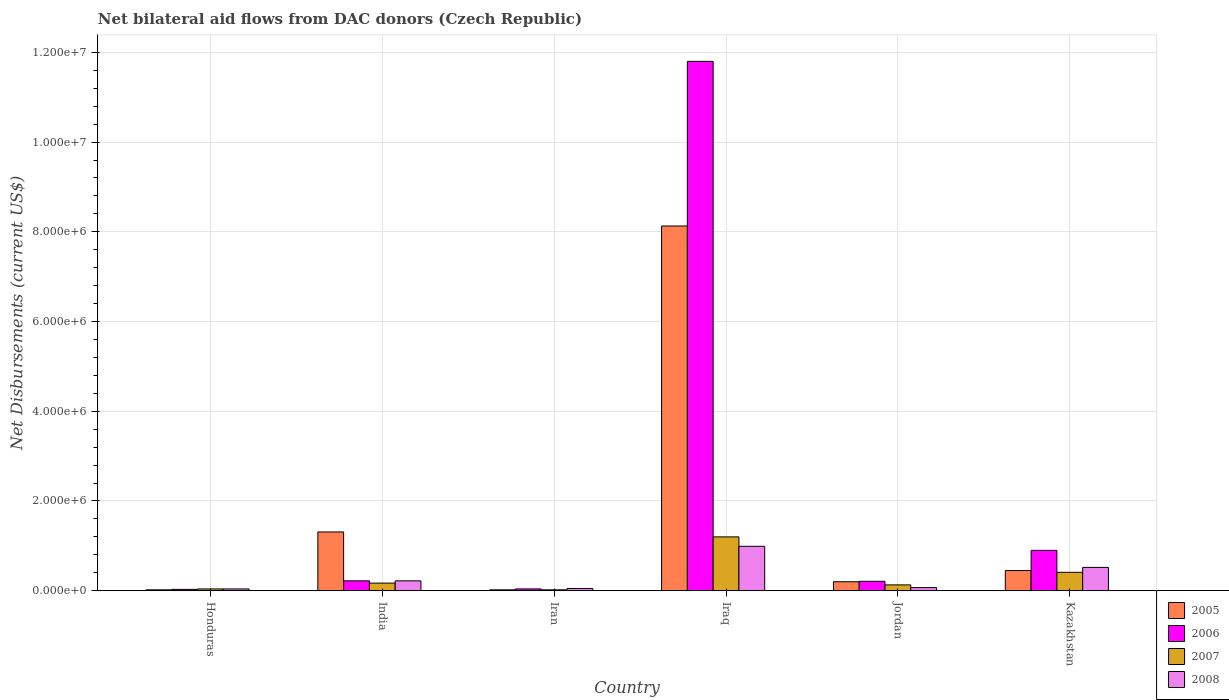How many different coloured bars are there?
Your answer should be very brief. 4. Are the number of bars per tick equal to the number of legend labels?
Provide a succinct answer. Yes. Are the number of bars on each tick of the X-axis equal?
Offer a terse response. Yes. How many bars are there on the 5th tick from the left?
Make the answer very short. 4. In how many cases, is the number of bars for a given country not equal to the number of legend labels?
Offer a very short reply. 0. Across all countries, what is the maximum net bilateral aid flows in 2007?
Provide a short and direct response. 1.20e+06. In which country was the net bilateral aid flows in 2006 maximum?
Provide a succinct answer. Iraq. In which country was the net bilateral aid flows in 2007 minimum?
Ensure brevity in your answer.  Iran. What is the total net bilateral aid flows in 2007 in the graph?
Offer a very short reply. 1.97e+06. What is the difference between the net bilateral aid flows in 2006 in Honduras and that in Iran?
Offer a very short reply. -10000. What is the difference between the net bilateral aid flows in 2007 in Iran and the net bilateral aid flows in 2005 in Jordan?
Your answer should be compact. -1.80e+05. What is the average net bilateral aid flows in 2008 per country?
Offer a terse response. 3.15e+05. Is the difference between the net bilateral aid flows in 2005 in Honduras and Jordan greater than the difference between the net bilateral aid flows in 2006 in Honduras and Jordan?
Keep it short and to the point. No. What is the difference between the highest and the second highest net bilateral aid flows in 2005?
Provide a short and direct response. 6.82e+06. What is the difference between the highest and the lowest net bilateral aid flows in 2006?
Offer a terse response. 1.18e+07. In how many countries, is the net bilateral aid flows in 2006 greater than the average net bilateral aid flows in 2006 taken over all countries?
Give a very brief answer. 1. Is the sum of the net bilateral aid flows in 2005 in Iran and Iraq greater than the maximum net bilateral aid flows in 2008 across all countries?
Your answer should be compact. Yes. What does the 4th bar from the right in Honduras represents?
Your answer should be very brief. 2005. Is it the case that in every country, the sum of the net bilateral aid flows in 2008 and net bilateral aid flows in 2006 is greater than the net bilateral aid flows in 2005?
Keep it short and to the point. No. How many countries are there in the graph?
Provide a short and direct response. 6. What is the difference between two consecutive major ticks on the Y-axis?
Provide a short and direct response. 2.00e+06. Does the graph contain grids?
Offer a terse response. Yes. What is the title of the graph?
Give a very brief answer. Net bilateral aid flows from DAC donors (Czech Republic). Does "1960" appear as one of the legend labels in the graph?
Give a very brief answer. No. What is the label or title of the X-axis?
Your answer should be very brief. Country. What is the label or title of the Y-axis?
Your answer should be very brief. Net Disbursements (current US$). What is the Net Disbursements (current US$) in 2005 in Honduras?
Your answer should be very brief. 2.00e+04. What is the Net Disbursements (current US$) in 2006 in Honduras?
Ensure brevity in your answer.  3.00e+04. What is the Net Disbursements (current US$) in 2007 in Honduras?
Your response must be concise. 4.00e+04. What is the Net Disbursements (current US$) of 2008 in Honduras?
Offer a terse response. 4.00e+04. What is the Net Disbursements (current US$) in 2005 in India?
Make the answer very short. 1.31e+06. What is the Net Disbursements (current US$) of 2007 in Iran?
Provide a succinct answer. 2.00e+04. What is the Net Disbursements (current US$) of 2008 in Iran?
Keep it short and to the point. 5.00e+04. What is the Net Disbursements (current US$) in 2005 in Iraq?
Keep it short and to the point. 8.13e+06. What is the Net Disbursements (current US$) in 2006 in Iraq?
Offer a very short reply. 1.18e+07. What is the Net Disbursements (current US$) in 2007 in Iraq?
Offer a terse response. 1.20e+06. What is the Net Disbursements (current US$) of 2008 in Iraq?
Give a very brief answer. 9.90e+05. What is the Net Disbursements (current US$) in 2006 in Kazakhstan?
Your response must be concise. 9.00e+05. What is the Net Disbursements (current US$) of 2008 in Kazakhstan?
Offer a very short reply. 5.20e+05. Across all countries, what is the maximum Net Disbursements (current US$) of 2005?
Offer a terse response. 8.13e+06. Across all countries, what is the maximum Net Disbursements (current US$) of 2006?
Offer a terse response. 1.18e+07. Across all countries, what is the maximum Net Disbursements (current US$) of 2007?
Ensure brevity in your answer.  1.20e+06. Across all countries, what is the maximum Net Disbursements (current US$) in 2008?
Your response must be concise. 9.90e+05. Across all countries, what is the minimum Net Disbursements (current US$) in 2005?
Provide a short and direct response. 2.00e+04. Across all countries, what is the minimum Net Disbursements (current US$) of 2006?
Keep it short and to the point. 3.00e+04. Across all countries, what is the minimum Net Disbursements (current US$) in 2007?
Your response must be concise. 2.00e+04. Across all countries, what is the minimum Net Disbursements (current US$) in 2008?
Provide a short and direct response. 4.00e+04. What is the total Net Disbursements (current US$) of 2005 in the graph?
Your response must be concise. 1.01e+07. What is the total Net Disbursements (current US$) in 2006 in the graph?
Your answer should be compact. 1.32e+07. What is the total Net Disbursements (current US$) in 2007 in the graph?
Your answer should be compact. 1.97e+06. What is the total Net Disbursements (current US$) of 2008 in the graph?
Your answer should be very brief. 1.89e+06. What is the difference between the Net Disbursements (current US$) in 2005 in Honduras and that in India?
Provide a short and direct response. -1.29e+06. What is the difference between the Net Disbursements (current US$) of 2005 in Honduras and that in Iran?
Offer a terse response. 0. What is the difference between the Net Disbursements (current US$) of 2007 in Honduras and that in Iran?
Your response must be concise. 2.00e+04. What is the difference between the Net Disbursements (current US$) in 2008 in Honduras and that in Iran?
Ensure brevity in your answer.  -10000. What is the difference between the Net Disbursements (current US$) of 2005 in Honduras and that in Iraq?
Provide a short and direct response. -8.11e+06. What is the difference between the Net Disbursements (current US$) in 2006 in Honduras and that in Iraq?
Your response must be concise. -1.18e+07. What is the difference between the Net Disbursements (current US$) of 2007 in Honduras and that in Iraq?
Keep it short and to the point. -1.16e+06. What is the difference between the Net Disbursements (current US$) in 2008 in Honduras and that in Iraq?
Make the answer very short. -9.50e+05. What is the difference between the Net Disbursements (current US$) of 2005 in Honduras and that in Jordan?
Make the answer very short. -1.80e+05. What is the difference between the Net Disbursements (current US$) in 2007 in Honduras and that in Jordan?
Your answer should be compact. -9.00e+04. What is the difference between the Net Disbursements (current US$) of 2008 in Honduras and that in Jordan?
Your answer should be compact. -3.00e+04. What is the difference between the Net Disbursements (current US$) of 2005 in Honduras and that in Kazakhstan?
Offer a very short reply. -4.30e+05. What is the difference between the Net Disbursements (current US$) in 2006 in Honduras and that in Kazakhstan?
Offer a very short reply. -8.70e+05. What is the difference between the Net Disbursements (current US$) in 2007 in Honduras and that in Kazakhstan?
Provide a succinct answer. -3.70e+05. What is the difference between the Net Disbursements (current US$) of 2008 in Honduras and that in Kazakhstan?
Give a very brief answer. -4.80e+05. What is the difference between the Net Disbursements (current US$) in 2005 in India and that in Iran?
Your answer should be compact. 1.29e+06. What is the difference between the Net Disbursements (current US$) in 2005 in India and that in Iraq?
Your response must be concise. -6.82e+06. What is the difference between the Net Disbursements (current US$) in 2006 in India and that in Iraq?
Give a very brief answer. -1.16e+07. What is the difference between the Net Disbursements (current US$) of 2007 in India and that in Iraq?
Offer a very short reply. -1.03e+06. What is the difference between the Net Disbursements (current US$) in 2008 in India and that in Iraq?
Make the answer very short. -7.70e+05. What is the difference between the Net Disbursements (current US$) in 2005 in India and that in Jordan?
Offer a very short reply. 1.11e+06. What is the difference between the Net Disbursements (current US$) in 2006 in India and that in Jordan?
Make the answer very short. 10000. What is the difference between the Net Disbursements (current US$) of 2007 in India and that in Jordan?
Make the answer very short. 4.00e+04. What is the difference between the Net Disbursements (current US$) of 2005 in India and that in Kazakhstan?
Provide a succinct answer. 8.60e+05. What is the difference between the Net Disbursements (current US$) in 2006 in India and that in Kazakhstan?
Offer a very short reply. -6.80e+05. What is the difference between the Net Disbursements (current US$) of 2007 in India and that in Kazakhstan?
Offer a very short reply. -2.40e+05. What is the difference between the Net Disbursements (current US$) in 2008 in India and that in Kazakhstan?
Offer a very short reply. -3.00e+05. What is the difference between the Net Disbursements (current US$) of 2005 in Iran and that in Iraq?
Ensure brevity in your answer.  -8.11e+06. What is the difference between the Net Disbursements (current US$) in 2006 in Iran and that in Iraq?
Offer a very short reply. -1.18e+07. What is the difference between the Net Disbursements (current US$) in 2007 in Iran and that in Iraq?
Give a very brief answer. -1.18e+06. What is the difference between the Net Disbursements (current US$) in 2008 in Iran and that in Iraq?
Offer a very short reply. -9.40e+05. What is the difference between the Net Disbursements (current US$) in 2005 in Iran and that in Jordan?
Keep it short and to the point. -1.80e+05. What is the difference between the Net Disbursements (current US$) in 2007 in Iran and that in Jordan?
Make the answer very short. -1.10e+05. What is the difference between the Net Disbursements (current US$) in 2005 in Iran and that in Kazakhstan?
Keep it short and to the point. -4.30e+05. What is the difference between the Net Disbursements (current US$) in 2006 in Iran and that in Kazakhstan?
Keep it short and to the point. -8.60e+05. What is the difference between the Net Disbursements (current US$) of 2007 in Iran and that in Kazakhstan?
Keep it short and to the point. -3.90e+05. What is the difference between the Net Disbursements (current US$) in 2008 in Iran and that in Kazakhstan?
Provide a short and direct response. -4.70e+05. What is the difference between the Net Disbursements (current US$) in 2005 in Iraq and that in Jordan?
Give a very brief answer. 7.93e+06. What is the difference between the Net Disbursements (current US$) in 2006 in Iraq and that in Jordan?
Provide a succinct answer. 1.16e+07. What is the difference between the Net Disbursements (current US$) in 2007 in Iraq and that in Jordan?
Provide a succinct answer. 1.07e+06. What is the difference between the Net Disbursements (current US$) in 2008 in Iraq and that in Jordan?
Ensure brevity in your answer.  9.20e+05. What is the difference between the Net Disbursements (current US$) in 2005 in Iraq and that in Kazakhstan?
Offer a terse response. 7.68e+06. What is the difference between the Net Disbursements (current US$) of 2006 in Iraq and that in Kazakhstan?
Keep it short and to the point. 1.09e+07. What is the difference between the Net Disbursements (current US$) of 2007 in Iraq and that in Kazakhstan?
Offer a very short reply. 7.90e+05. What is the difference between the Net Disbursements (current US$) of 2006 in Jordan and that in Kazakhstan?
Keep it short and to the point. -6.90e+05. What is the difference between the Net Disbursements (current US$) in 2007 in Jordan and that in Kazakhstan?
Your answer should be very brief. -2.80e+05. What is the difference between the Net Disbursements (current US$) in 2008 in Jordan and that in Kazakhstan?
Give a very brief answer. -4.50e+05. What is the difference between the Net Disbursements (current US$) of 2005 in Honduras and the Net Disbursements (current US$) of 2006 in India?
Offer a very short reply. -2.00e+05. What is the difference between the Net Disbursements (current US$) of 2005 in Honduras and the Net Disbursements (current US$) of 2007 in Iran?
Keep it short and to the point. 0. What is the difference between the Net Disbursements (current US$) of 2006 in Honduras and the Net Disbursements (current US$) of 2007 in Iran?
Your answer should be compact. 10000. What is the difference between the Net Disbursements (current US$) of 2006 in Honduras and the Net Disbursements (current US$) of 2008 in Iran?
Your answer should be compact. -2.00e+04. What is the difference between the Net Disbursements (current US$) of 2005 in Honduras and the Net Disbursements (current US$) of 2006 in Iraq?
Your answer should be very brief. -1.18e+07. What is the difference between the Net Disbursements (current US$) in 2005 in Honduras and the Net Disbursements (current US$) in 2007 in Iraq?
Offer a terse response. -1.18e+06. What is the difference between the Net Disbursements (current US$) in 2005 in Honduras and the Net Disbursements (current US$) in 2008 in Iraq?
Your answer should be very brief. -9.70e+05. What is the difference between the Net Disbursements (current US$) of 2006 in Honduras and the Net Disbursements (current US$) of 2007 in Iraq?
Provide a short and direct response. -1.17e+06. What is the difference between the Net Disbursements (current US$) in 2006 in Honduras and the Net Disbursements (current US$) in 2008 in Iraq?
Offer a terse response. -9.60e+05. What is the difference between the Net Disbursements (current US$) of 2007 in Honduras and the Net Disbursements (current US$) of 2008 in Iraq?
Offer a very short reply. -9.50e+05. What is the difference between the Net Disbursements (current US$) of 2005 in Honduras and the Net Disbursements (current US$) of 2006 in Jordan?
Give a very brief answer. -1.90e+05. What is the difference between the Net Disbursements (current US$) in 2005 in Honduras and the Net Disbursements (current US$) in 2007 in Jordan?
Give a very brief answer. -1.10e+05. What is the difference between the Net Disbursements (current US$) in 2006 in Honduras and the Net Disbursements (current US$) in 2007 in Jordan?
Provide a succinct answer. -1.00e+05. What is the difference between the Net Disbursements (current US$) in 2006 in Honduras and the Net Disbursements (current US$) in 2008 in Jordan?
Your answer should be very brief. -4.00e+04. What is the difference between the Net Disbursements (current US$) of 2007 in Honduras and the Net Disbursements (current US$) of 2008 in Jordan?
Your response must be concise. -3.00e+04. What is the difference between the Net Disbursements (current US$) in 2005 in Honduras and the Net Disbursements (current US$) in 2006 in Kazakhstan?
Keep it short and to the point. -8.80e+05. What is the difference between the Net Disbursements (current US$) of 2005 in Honduras and the Net Disbursements (current US$) of 2007 in Kazakhstan?
Your answer should be very brief. -3.90e+05. What is the difference between the Net Disbursements (current US$) in 2005 in Honduras and the Net Disbursements (current US$) in 2008 in Kazakhstan?
Provide a short and direct response. -5.00e+05. What is the difference between the Net Disbursements (current US$) of 2006 in Honduras and the Net Disbursements (current US$) of 2007 in Kazakhstan?
Offer a terse response. -3.80e+05. What is the difference between the Net Disbursements (current US$) in 2006 in Honduras and the Net Disbursements (current US$) in 2008 in Kazakhstan?
Make the answer very short. -4.90e+05. What is the difference between the Net Disbursements (current US$) of 2007 in Honduras and the Net Disbursements (current US$) of 2008 in Kazakhstan?
Offer a very short reply. -4.80e+05. What is the difference between the Net Disbursements (current US$) in 2005 in India and the Net Disbursements (current US$) in 2006 in Iran?
Your response must be concise. 1.27e+06. What is the difference between the Net Disbursements (current US$) of 2005 in India and the Net Disbursements (current US$) of 2007 in Iran?
Keep it short and to the point. 1.29e+06. What is the difference between the Net Disbursements (current US$) in 2005 in India and the Net Disbursements (current US$) in 2008 in Iran?
Your response must be concise. 1.26e+06. What is the difference between the Net Disbursements (current US$) of 2006 in India and the Net Disbursements (current US$) of 2007 in Iran?
Your answer should be very brief. 2.00e+05. What is the difference between the Net Disbursements (current US$) of 2006 in India and the Net Disbursements (current US$) of 2008 in Iran?
Keep it short and to the point. 1.70e+05. What is the difference between the Net Disbursements (current US$) in 2007 in India and the Net Disbursements (current US$) in 2008 in Iran?
Make the answer very short. 1.20e+05. What is the difference between the Net Disbursements (current US$) of 2005 in India and the Net Disbursements (current US$) of 2006 in Iraq?
Your response must be concise. -1.05e+07. What is the difference between the Net Disbursements (current US$) in 2005 in India and the Net Disbursements (current US$) in 2007 in Iraq?
Your answer should be compact. 1.10e+05. What is the difference between the Net Disbursements (current US$) of 2005 in India and the Net Disbursements (current US$) of 2008 in Iraq?
Give a very brief answer. 3.20e+05. What is the difference between the Net Disbursements (current US$) of 2006 in India and the Net Disbursements (current US$) of 2007 in Iraq?
Keep it short and to the point. -9.80e+05. What is the difference between the Net Disbursements (current US$) in 2006 in India and the Net Disbursements (current US$) in 2008 in Iraq?
Offer a very short reply. -7.70e+05. What is the difference between the Net Disbursements (current US$) in 2007 in India and the Net Disbursements (current US$) in 2008 in Iraq?
Ensure brevity in your answer.  -8.20e+05. What is the difference between the Net Disbursements (current US$) in 2005 in India and the Net Disbursements (current US$) in 2006 in Jordan?
Offer a very short reply. 1.10e+06. What is the difference between the Net Disbursements (current US$) of 2005 in India and the Net Disbursements (current US$) of 2007 in Jordan?
Your answer should be very brief. 1.18e+06. What is the difference between the Net Disbursements (current US$) of 2005 in India and the Net Disbursements (current US$) of 2008 in Jordan?
Offer a very short reply. 1.24e+06. What is the difference between the Net Disbursements (current US$) of 2007 in India and the Net Disbursements (current US$) of 2008 in Jordan?
Keep it short and to the point. 1.00e+05. What is the difference between the Net Disbursements (current US$) in 2005 in India and the Net Disbursements (current US$) in 2007 in Kazakhstan?
Provide a short and direct response. 9.00e+05. What is the difference between the Net Disbursements (current US$) in 2005 in India and the Net Disbursements (current US$) in 2008 in Kazakhstan?
Your response must be concise. 7.90e+05. What is the difference between the Net Disbursements (current US$) in 2007 in India and the Net Disbursements (current US$) in 2008 in Kazakhstan?
Your answer should be very brief. -3.50e+05. What is the difference between the Net Disbursements (current US$) of 2005 in Iran and the Net Disbursements (current US$) of 2006 in Iraq?
Provide a short and direct response. -1.18e+07. What is the difference between the Net Disbursements (current US$) in 2005 in Iran and the Net Disbursements (current US$) in 2007 in Iraq?
Make the answer very short. -1.18e+06. What is the difference between the Net Disbursements (current US$) in 2005 in Iran and the Net Disbursements (current US$) in 2008 in Iraq?
Ensure brevity in your answer.  -9.70e+05. What is the difference between the Net Disbursements (current US$) of 2006 in Iran and the Net Disbursements (current US$) of 2007 in Iraq?
Your answer should be very brief. -1.16e+06. What is the difference between the Net Disbursements (current US$) in 2006 in Iran and the Net Disbursements (current US$) in 2008 in Iraq?
Your response must be concise. -9.50e+05. What is the difference between the Net Disbursements (current US$) in 2007 in Iran and the Net Disbursements (current US$) in 2008 in Iraq?
Offer a very short reply. -9.70e+05. What is the difference between the Net Disbursements (current US$) of 2005 in Iran and the Net Disbursements (current US$) of 2006 in Jordan?
Your answer should be very brief. -1.90e+05. What is the difference between the Net Disbursements (current US$) of 2005 in Iran and the Net Disbursements (current US$) of 2007 in Jordan?
Keep it short and to the point. -1.10e+05. What is the difference between the Net Disbursements (current US$) of 2006 in Iran and the Net Disbursements (current US$) of 2008 in Jordan?
Offer a terse response. -3.00e+04. What is the difference between the Net Disbursements (current US$) of 2005 in Iran and the Net Disbursements (current US$) of 2006 in Kazakhstan?
Offer a very short reply. -8.80e+05. What is the difference between the Net Disbursements (current US$) of 2005 in Iran and the Net Disbursements (current US$) of 2007 in Kazakhstan?
Provide a succinct answer. -3.90e+05. What is the difference between the Net Disbursements (current US$) of 2005 in Iran and the Net Disbursements (current US$) of 2008 in Kazakhstan?
Offer a terse response. -5.00e+05. What is the difference between the Net Disbursements (current US$) in 2006 in Iran and the Net Disbursements (current US$) in 2007 in Kazakhstan?
Keep it short and to the point. -3.70e+05. What is the difference between the Net Disbursements (current US$) in 2006 in Iran and the Net Disbursements (current US$) in 2008 in Kazakhstan?
Keep it short and to the point. -4.80e+05. What is the difference between the Net Disbursements (current US$) of 2007 in Iran and the Net Disbursements (current US$) of 2008 in Kazakhstan?
Your response must be concise. -5.00e+05. What is the difference between the Net Disbursements (current US$) of 2005 in Iraq and the Net Disbursements (current US$) of 2006 in Jordan?
Your answer should be very brief. 7.92e+06. What is the difference between the Net Disbursements (current US$) in 2005 in Iraq and the Net Disbursements (current US$) in 2007 in Jordan?
Ensure brevity in your answer.  8.00e+06. What is the difference between the Net Disbursements (current US$) in 2005 in Iraq and the Net Disbursements (current US$) in 2008 in Jordan?
Make the answer very short. 8.06e+06. What is the difference between the Net Disbursements (current US$) of 2006 in Iraq and the Net Disbursements (current US$) of 2007 in Jordan?
Your response must be concise. 1.17e+07. What is the difference between the Net Disbursements (current US$) in 2006 in Iraq and the Net Disbursements (current US$) in 2008 in Jordan?
Make the answer very short. 1.17e+07. What is the difference between the Net Disbursements (current US$) of 2007 in Iraq and the Net Disbursements (current US$) of 2008 in Jordan?
Offer a very short reply. 1.13e+06. What is the difference between the Net Disbursements (current US$) of 2005 in Iraq and the Net Disbursements (current US$) of 2006 in Kazakhstan?
Your answer should be very brief. 7.23e+06. What is the difference between the Net Disbursements (current US$) of 2005 in Iraq and the Net Disbursements (current US$) of 2007 in Kazakhstan?
Give a very brief answer. 7.72e+06. What is the difference between the Net Disbursements (current US$) of 2005 in Iraq and the Net Disbursements (current US$) of 2008 in Kazakhstan?
Your answer should be compact. 7.61e+06. What is the difference between the Net Disbursements (current US$) of 2006 in Iraq and the Net Disbursements (current US$) of 2007 in Kazakhstan?
Make the answer very short. 1.14e+07. What is the difference between the Net Disbursements (current US$) of 2006 in Iraq and the Net Disbursements (current US$) of 2008 in Kazakhstan?
Your answer should be compact. 1.13e+07. What is the difference between the Net Disbursements (current US$) of 2007 in Iraq and the Net Disbursements (current US$) of 2008 in Kazakhstan?
Offer a very short reply. 6.80e+05. What is the difference between the Net Disbursements (current US$) of 2005 in Jordan and the Net Disbursements (current US$) of 2006 in Kazakhstan?
Keep it short and to the point. -7.00e+05. What is the difference between the Net Disbursements (current US$) of 2005 in Jordan and the Net Disbursements (current US$) of 2008 in Kazakhstan?
Provide a short and direct response. -3.20e+05. What is the difference between the Net Disbursements (current US$) in 2006 in Jordan and the Net Disbursements (current US$) in 2008 in Kazakhstan?
Provide a short and direct response. -3.10e+05. What is the difference between the Net Disbursements (current US$) of 2007 in Jordan and the Net Disbursements (current US$) of 2008 in Kazakhstan?
Make the answer very short. -3.90e+05. What is the average Net Disbursements (current US$) in 2005 per country?
Give a very brief answer. 1.69e+06. What is the average Net Disbursements (current US$) of 2006 per country?
Offer a terse response. 2.20e+06. What is the average Net Disbursements (current US$) of 2007 per country?
Offer a very short reply. 3.28e+05. What is the average Net Disbursements (current US$) in 2008 per country?
Your answer should be compact. 3.15e+05. What is the difference between the Net Disbursements (current US$) of 2005 and Net Disbursements (current US$) of 2007 in Honduras?
Your answer should be very brief. -2.00e+04. What is the difference between the Net Disbursements (current US$) of 2005 and Net Disbursements (current US$) of 2008 in Honduras?
Offer a terse response. -2.00e+04. What is the difference between the Net Disbursements (current US$) in 2006 and Net Disbursements (current US$) in 2007 in Honduras?
Provide a short and direct response. -10000. What is the difference between the Net Disbursements (current US$) of 2007 and Net Disbursements (current US$) of 2008 in Honduras?
Your answer should be compact. 0. What is the difference between the Net Disbursements (current US$) in 2005 and Net Disbursements (current US$) in 2006 in India?
Offer a very short reply. 1.09e+06. What is the difference between the Net Disbursements (current US$) in 2005 and Net Disbursements (current US$) in 2007 in India?
Your answer should be compact. 1.14e+06. What is the difference between the Net Disbursements (current US$) of 2005 and Net Disbursements (current US$) of 2008 in India?
Your answer should be compact. 1.09e+06. What is the difference between the Net Disbursements (current US$) in 2007 and Net Disbursements (current US$) in 2008 in India?
Provide a short and direct response. -5.00e+04. What is the difference between the Net Disbursements (current US$) in 2005 and Net Disbursements (current US$) in 2006 in Iran?
Your answer should be compact. -2.00e+04. What is the difference between the Net Disbursements (current US$) in 2005 and Net Disbursements (current US$) in 2007 in Iran?
Ensure brevity in your answer.  0. What is the difference between the Net Disbursements (current US$) in 2005 and Net Disbursements (current US$) in 2008 in Iran?
Your answer should be very brief. -3.00e+04. What is the difference between the Net Disbursements (current US$) of 2006 and Net Disbursements (current US$) of 2008 in Iran?
Your response must be concise. -10000. What is the difference between the Net Disbursements (current US$) in 2005 and Net Disbursements (current US$) in 2006 in Iraq?
Your answer should be compact. -3.67e+06. What is the difference between the Net Disbursements (current US$) in 2005 and Net Disbursements (current US$) in 2007 in Iraq?
Ensure brevity in your answer.  6.93e+06. What is the difference between the Net Disbursements (current US$) in 2005 and Net Disbursements (current US$) in 2008 in Iraq?
Make the answer very short. 7.14e+06. What is the difference between the Net Disbursements (current US$) of 2006 and Net Disbursements (current US$) of 2007 in Iraq?
Ensure brevity in your answer.  1.06e+07. What is the difference between the Net Disbursements (current US$) of 2006 and Net Disbursements (current US$) of 2008 in Iraq?
Offer a very short reply. 1.08e+07. What is the difference between the Net Disbursements (current US$) in 2007 and Net Disbursements (current US$) in 2008 in Iraq?
Ensure brevity in your answer.  2.10e+05. What is the difference between the Net Disbursements (current US$) of 2006 and Net Disbursements (current US$) of 2008 in Jordan?
Make the answer very short. 1.40e+05. What is the difference between the Net Disbursements (current US$) in 2005 and Net Disbursements (current US$) in 2006 in Kazakhstan?
Provide a short and direct response. -4.50e+05. What is the difference between the Net Disbursements (current US$) of 2006 and Net Disbursements (current US$) of 2008 in Kazakhstan?
Your response must be concise. 3.80e+05. What is the difference between the Net Disbursements (current US$) in 2007 and Net Disbursements (current US$) in 2008 in Kazakhstan?
Your response must be concise. -1.10e+05. What is the ratio of the Net Disbursements (current US$) of 2005 in Honduras to that in India?
Your answer should be compact. 0.02. What is the ratio of the Net Disbursements (current US$) of 2006 in Honduras to that in India?
Give a very brief answer. 0.14. What is the ratio of the Net Disbursements (current US$) in 2007 in Honduras to that in India?
Your answer should be very brief. 0.24. What is the ratio of the Net Disbursements (current US$) of 2008 in Honduras to that in India?
Offer a very short reply. 0.18. What is the ratio of the Net Disbursements (current US$) of 2007 in Honduras to that in Iran?
Give a very brief answer. 2. What is the ratio of the Net Disbursements (current US$) in 2008 in Honduras to that in Iran?
Your answer should be compact. 0.8. What is the ratio of the Net Disbursements (current US$) of 2005 in Honduras to that in Iraq?
Make the answer very short. 0. What is the ratio of the Net Disbursements (current US$) in 2006 in Honduras to that in Iraq?
Ensure brevity in your answer.  0. What is the ratio of the Net Disbursements (current US$) in 2008 in Honduras to that in Iraq?
Give a very brief answer. 0.04. What is the ratio of the Net Disbursements (current US$) of 2005 in Honduras to that in Jordan?
Offer a very short reply. 0.1. What is the ratio of the Net Disbursements (current US$) of 2006 in Honduras to that in Jordan?
Make the answer very short. 0.14. What is the ratio of the Net Disbursements (current US$) of 2007 in Honduras to that in Jordan?
Offer a terse response. 0.31. What is the ratio of the Net Disbursements (current US$) in 2005 in Honduras to that in Kazakhstan?
Your answer should be very brief. 0.04. What is the ratio of the Net Disbursements (current US$) in 2007 in Honduras to that in Kazakhstan?
Provide a short and direct response. 0.1. What is the ratio of the Net Disbursements (current US$) of 2008 in Honduras to that in Kazakhstan?
Offer a terse response. 0.08. What is the ratio of the Net Disbursements (current US$) of 2005 in India to that in Iran?
Offer a very short reply. 65.5. What is the ratio of the Net Disbursements (current US$) of 2005 in India to that in Iraq?
Make the answer very short. 0.16. What is the ratio of the Net Disbursements (current US$) of 2006 in India to that in Iraq?
Your answer should be very brief. 0.02. What is the ratio of the Net Disbursements (current US$) in 2007 in India to that in Iraq?
Your response must be concise. 0.14. What is the ratio of the Net Disbursements (current US$) in 2008 in India to that in Iraq?
Your answer should be very brief. 0.22. What is the ratio of the Net Disbursements (current US$) in 2005 in India to that in Jordan?
Provide a succinct answer. 6.55. What is the ratio of the Net Disbursements (current US$) in 2006 in India to that in Jordan?
Offer a terse response. 1.05. What is the ratio of the Net Disbursements (current US$) of 2007 in India to that in Jordan?
Ensure brevity in your answer.  1.31. What is the ratio of the Net Disbursements (current US$) of 2008 in India to that in Jordan?
Give a very brief answer. 3.14. What is the ratio of the Net Disbursements (current US$) of 2005 in India to that in Kazakhstan?
Offer a terse response. 2.91. What is the ratio of the Net Disbursements (current US$) in 2006 in India to that in Kazakhstan?
Offer a very short reply. 0.24. What is the ratio of the Net Disbursements (current US$) in 2007 in India to that in Kazakhstan?
Offer a terse response. 0.41. What is the ratio of the Net Disbursements (current US$) in 2008 in India to that in Kazakhstan?
Your answer should be compact. 0.42. What is the ratio of the Net Disbursements (current US$) in 2005 in Iran to that in Iraq?
Provide a short and direct response. 0. What is the ratio of the Net Disbursements (current US$) in 2006 in Iran to that in Iraq?
Make the answer very short. 0. What is the ratio of the Net Disbursements (current US$) of 2007 in Iran to that in Iraq?
Give a very brief answer. 0.02. What is the ratio of the Net Disbursements (current US$) in 2008 in Iran to that in Iraq?
Offer a terse response. 0.05. What is the ratio of the Net Disbursements (current US$) in 2006 in Iran to that in Jordan?
Make the answer very short. 0.19. What is the ratio of the Net Disbursements (current US$) in 2007 in Iran to that in Jordan?
Provide a succinct answer. 0.15. What is the ratio of the Net Disbursements (current US$) of 2008 in Iran to that in Jordan?
Provide a short and direct response. 0.71. What is the ratio of the Net Disbursements (current US$) in 2005 in Iran to that in Kazakhstan?
Make the answer very short. 0.04. What is the ratio of the Net Disbursements (current US$) of 2006 in Iran to that in Kazakhstan?
Offer a very short reply. 0.04. What is the ratio of the Net Disbursements (current US$) of 2007 in Iran to that in Kazakhstan?
Your answer should be compact. 0.05. What is the ratio of the Net Disbursements (current US$) in 2008 in Iran to that in Kazakhstan?
Your answer should be compact. 0.1. What is the ratio of the Net Disbursements (current US$) of 2005 in Iraq to that in Jordan?
Keep it short and to the point. 40.65. What is the ratio of the Net Disbursements (current US$) in 2006 in Iraq to that in Jordan?
Offer a terse response. 56.19. What is the ratio of the Net Disbursements (current US$) in 2007 in Iraq to that in Jordan?
Keep it short and to the point. 9.23. What is the ratio of the Net Disbursements (current US$) in 2008 in Iraq to that in Jordan?
Your answer should be very brief. 14.14. What is the ratio of the Net Disbursements (current US$) in 2005 in Iraq to that in Kazakhstan?
Your answer should be compact. 18.07. What is the ratio of the Net Disbursements (current US$) of 2006 in Iraq to that in Kazakhstan?
Give a very brief answer. 13.11. What is the ratio of the Net Disbursements (current US$) in 2007 in Iraq to that in Kazakhstan?
Provide a succinct answer. 2.93. What is the ratio of the Net Disbursements (current US$) of 2008 in Iraq to that in Kazakhstan?
Make the answer very short. 1.9. What is the ratio of the Net Disbursements (current US$) of 2005 in Jordan to that in Kazakhstan?
Your answer should be compact. 0.44. What is the ratio of the Net Disbursements (current US$) in 2006 in Jordan to that in Kazakhstan?
Provide a short and direct response. 0.23. What is the ratio of the Net Disbursements (current US$) in 2007 in Jordan to that in Kazakhstan?
Keep it short and to the point. 0.32. What is the ratio of the Net Disbursements (current US$) in 2008 in Jordan to that in Kazakhstan?
Your answer should be very brief. 0.13. What is the difference between the highest and the second highest Net Disbursements (current US$) in 2005?
Your response must be concise. 6.82e+06. What is the difference between the highest and the second highest Net Disbursements (current US$) in 2006?
Your response must be concise. 1.09e+07. What is the difference between the highest and the second highest Net Disbursements (current US$) of 2007?
Offer a terse response. 7.90e+05. What is the difference between the highest and the lowest Net Disbursements (current US$) in 2005?
Keep it short and to the point. 8.11e+06. What is the difference between the highest and the lowest Net Disbursements (current US$) of 2006?
Give a very brief answer. 1.18e+07. What is the difference between the highest and the lowest Net Disbursements (current US$) in 2007?
Keep it short and to the point. 1.18e+06. What is the difference between the highest and the lowest Net Disbursements (current US$) of 2008?
Provide a short and direct response. 9.50e+05. 